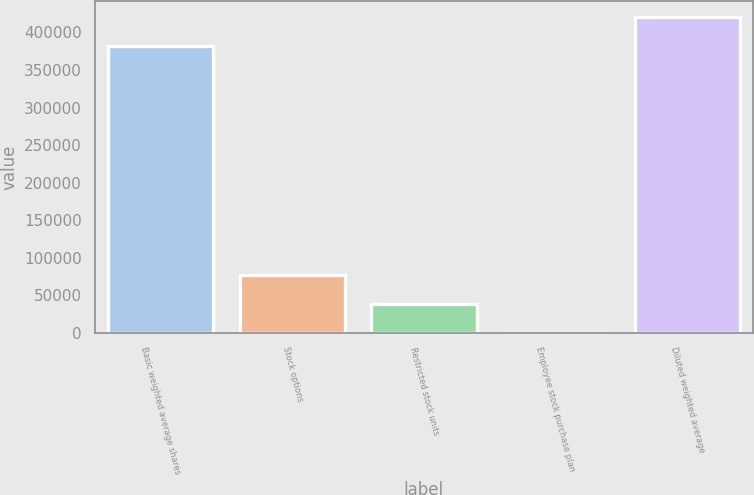<chart> <loc_0><loc_0><loc_500><loc_500><bar_chart><fcel>Basic weighted average shares<fcel>Stock options<fcel>Restricted stock units<fcel>Employee stock purchase plan<fcel>Diluted weighted average<nl><fcel>381782<fcel>76949.2<fcel>38497.1<fcel>45<fcel>420234<nl></chart> 